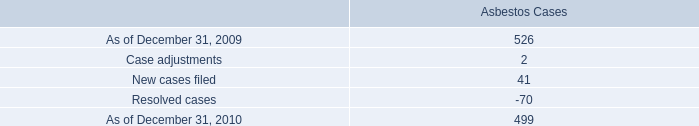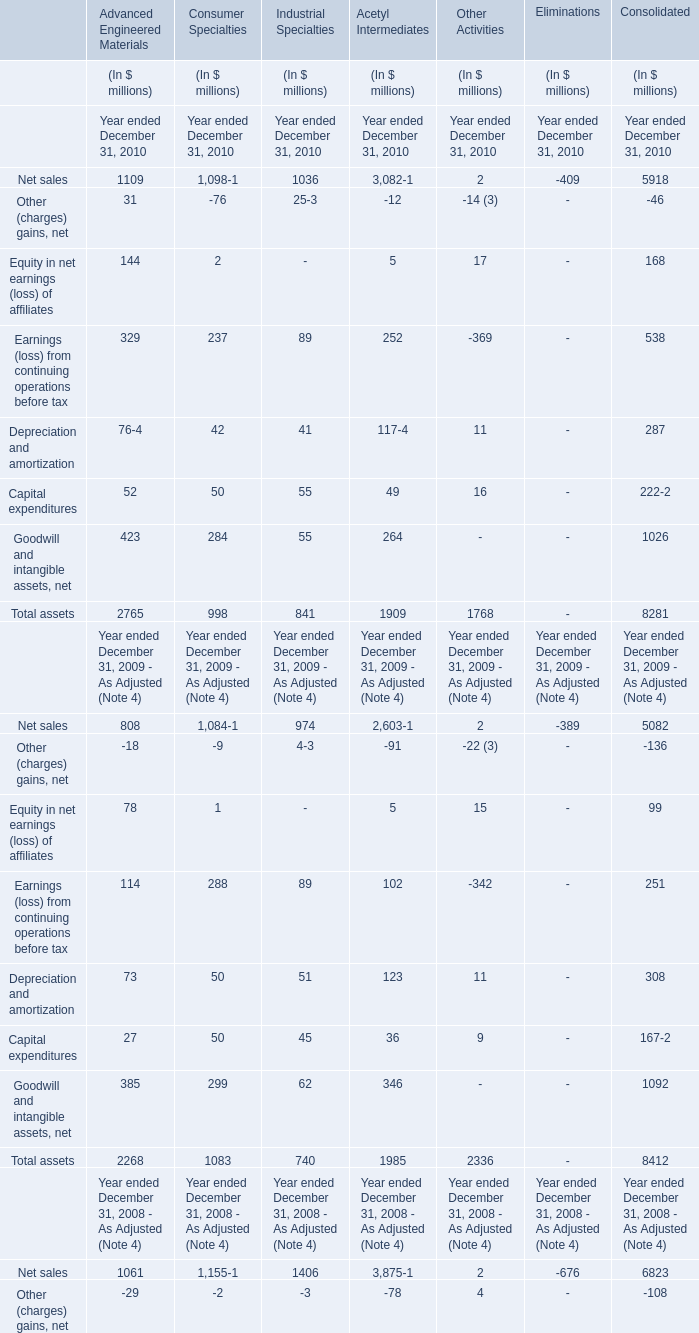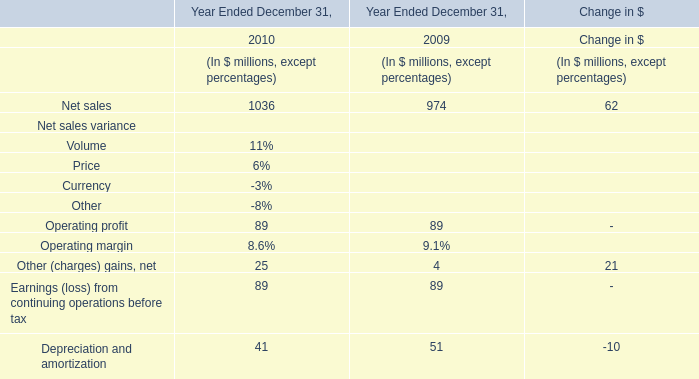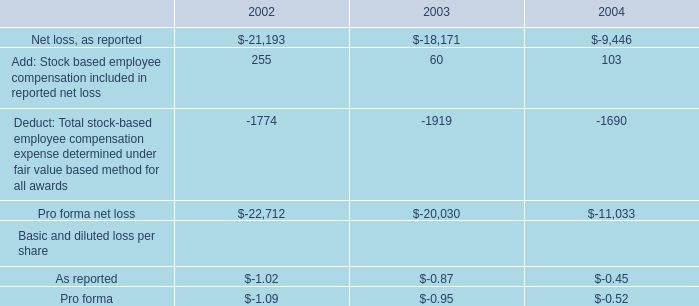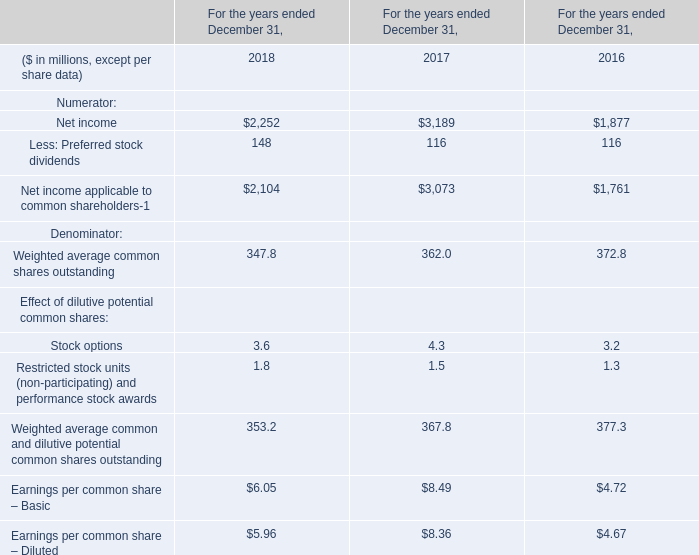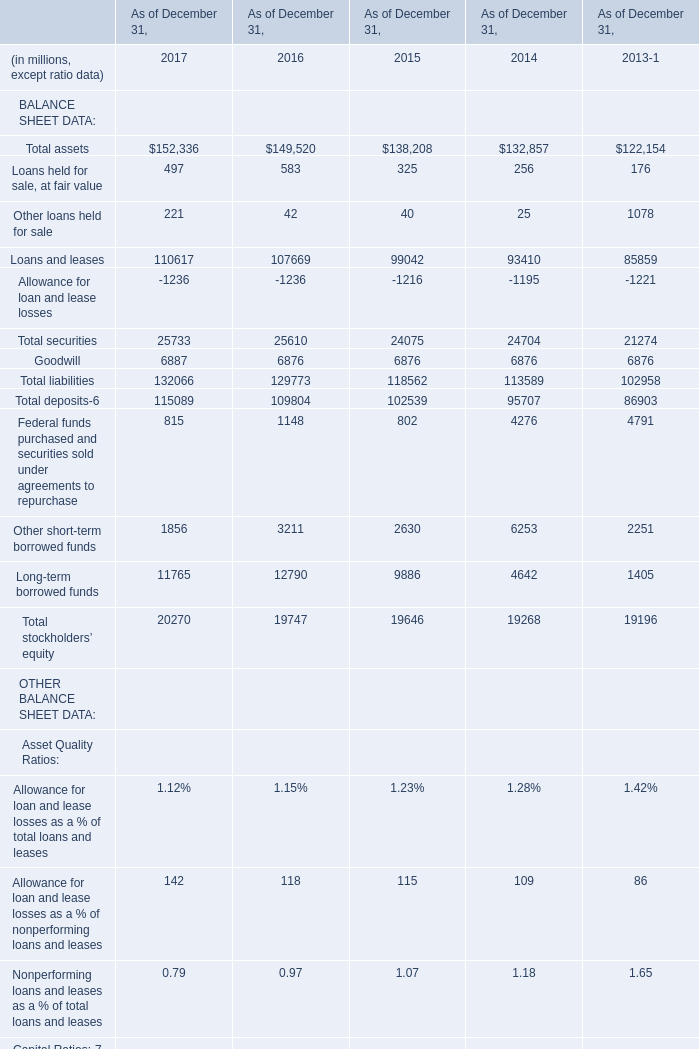What is the average increasing rate of net sale of Industrial Specialties between 2009 and 2010? 
Computations: ((((1036 - 974) / 974) + ((974 - 1406) / 1406)) / 2)
Answer: -0.1218. 